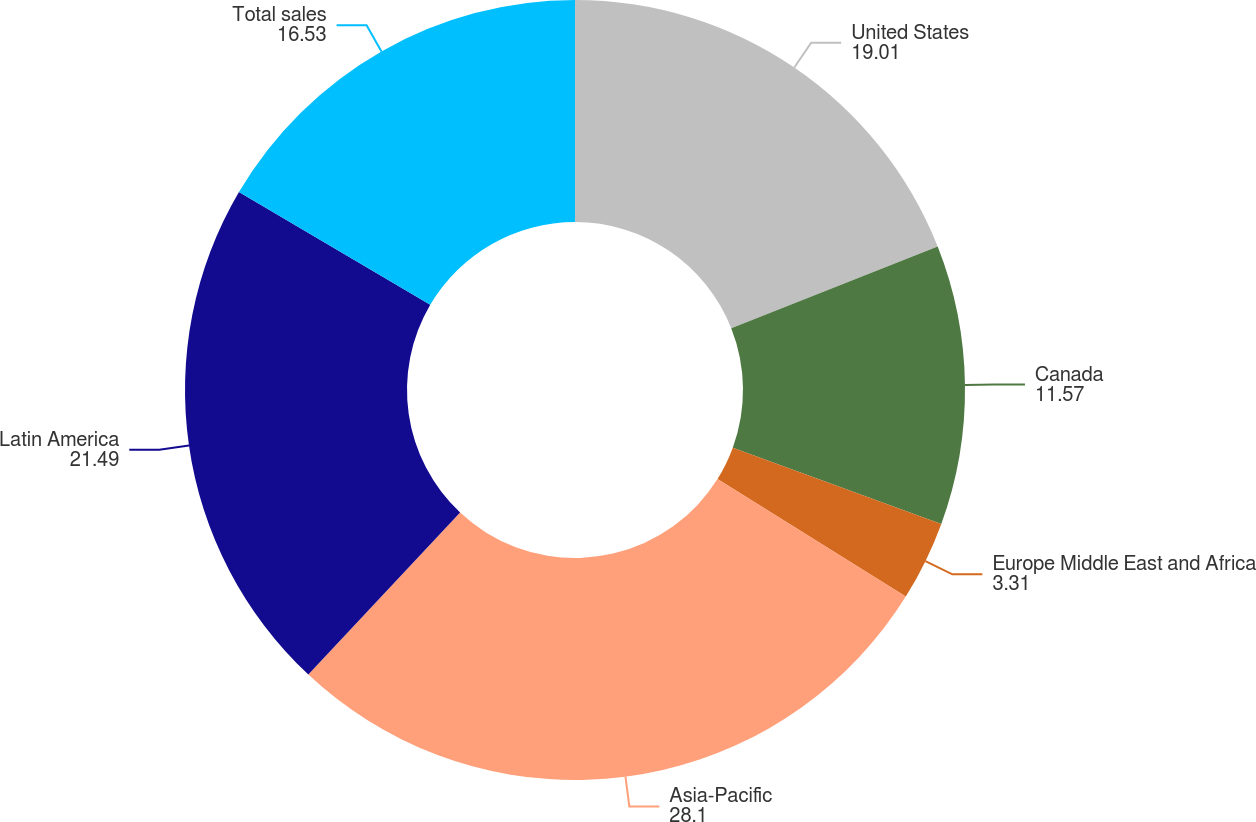Convert chart to OTSL. <chart><loc_0><loc_0><loc_500><loc_500><pie_chart><fcel>United States<fcel>Canada<fcel>Europe Middle East and Africa<fcel>Asia-Pacific<fcel>Latin America<fcel>Total sales<nl><fcel>19.01%<fcel>11.57%<fcel>3.31%<fcel>28.1%<fcel>21.49%<fcel>16.53%<nl></chart> 